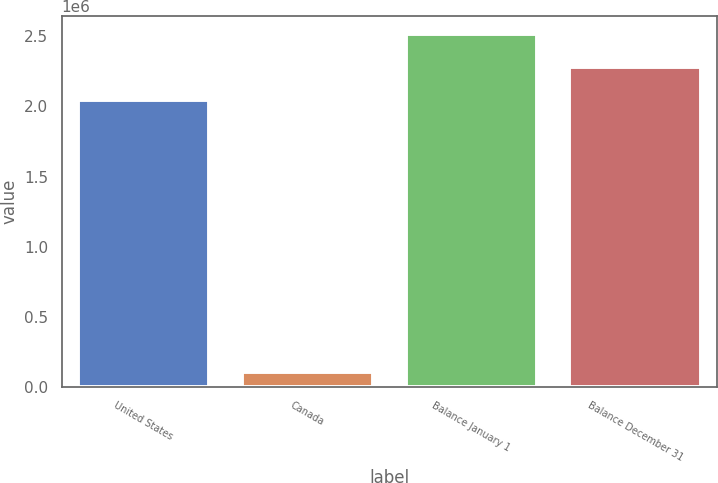<chart> <loc_0><loc_0><loc_500><loc_500><bar_chart><fcel>United States<fcel>Canada<fcel>Balance January 1<fcel>Balance December 31<nl><fcel>2.04528e+06<fcel>107547<fcel>2.51845e+06<fcel>2.28186e+06<nl></chart> 